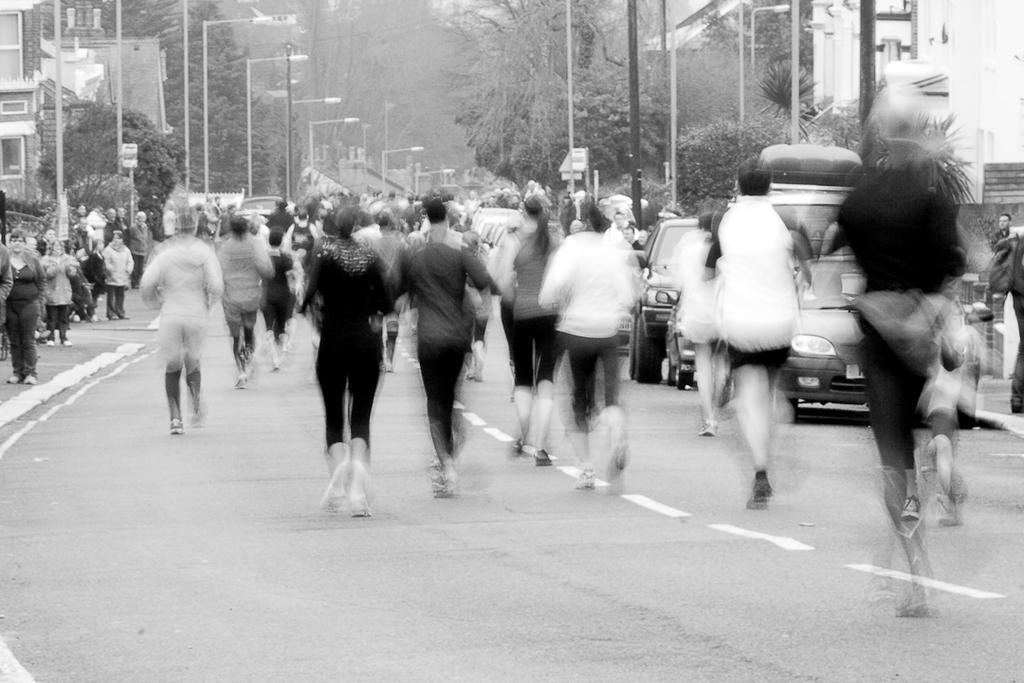Could you give a brief overview of what you see in this image? This is a black and white picture. There are vehicles and persons on the road. Here we can see poles, trees, and buildings. 